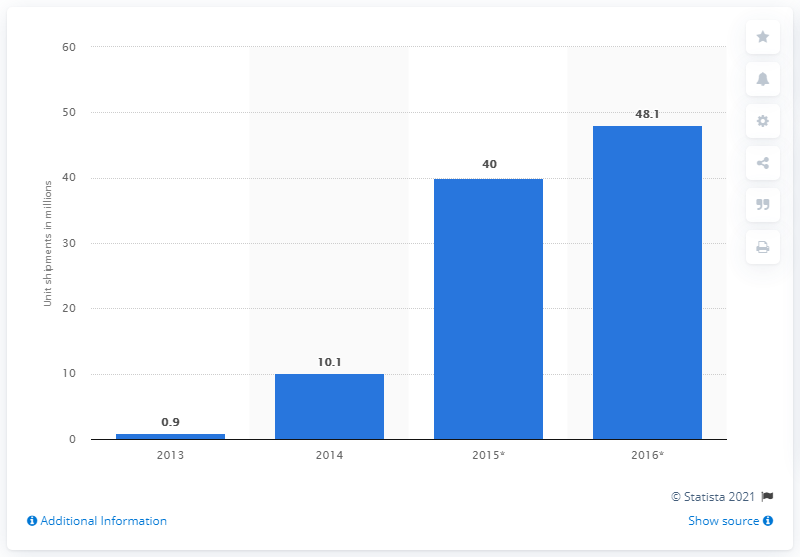Indicate a few pertinent items in this graphic. In 2014, approximately 10.1 million 4k Ultra HD TVs were shipped worldwide. According to estimates, 48.1 million 4k Ultra HD TVs were expected to be shipped by 2016. 